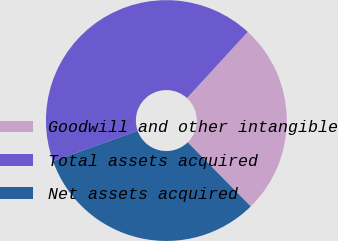Convert chart to OTSL. <chart><loc_0><loc_0><loc_500><loc_500><pie_chart><fcel>Goodwill and other intangible<fcel>Total assets acquired<fcel>Net assets acquired<nl><fcel>25.82%<fcel>42.29%<fcel>31.89%<nl></chart> 